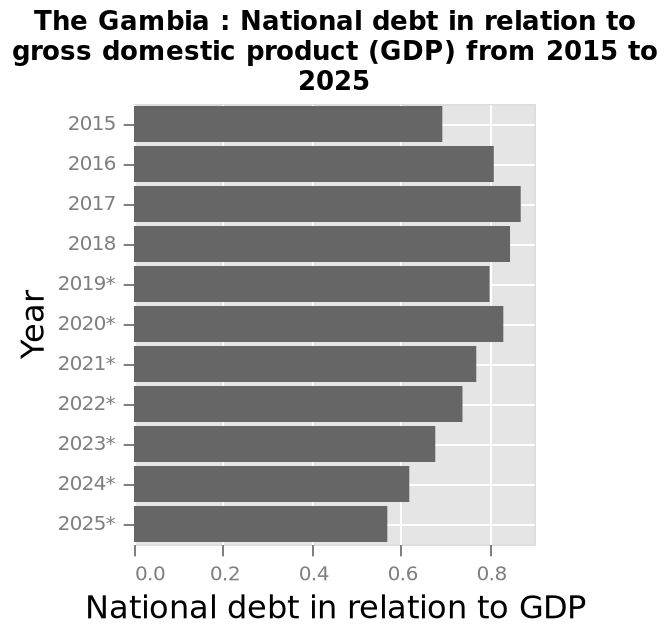<image>
What type of plot is used to represent the national debt in relation to GDP in The Gambia? A bar plot is used to represent the national debt in relation to GDP in The Gambia. please describe the details of the chart The Gambia : National debt in relation to gross domestic product (GDP) from 2015 to 2025 is a bar plot. Year is plotted using a categorical scale from 2015 to 2025* along the y-axis. Along the x-axis, National debt in relation to GDP is shown. What does the bar plot show about the national debt in relation to GDP in The Gambia? The bar plot shows the national debt in relation to GDP in The Gambia from 2015 to 2025. Is the National debt in relation to gross domestic product (GDP) from 2015 to 2025 a scatter plot? No.The Gambia : National debt in relation to gross domestic product (GDP) from 2015 to 2025 is a bar plot. Year is plotted using a categorical scale from 2015 to 2025* along the y-axis. Along the x-axis, National debt in relation to GDP is shown. 